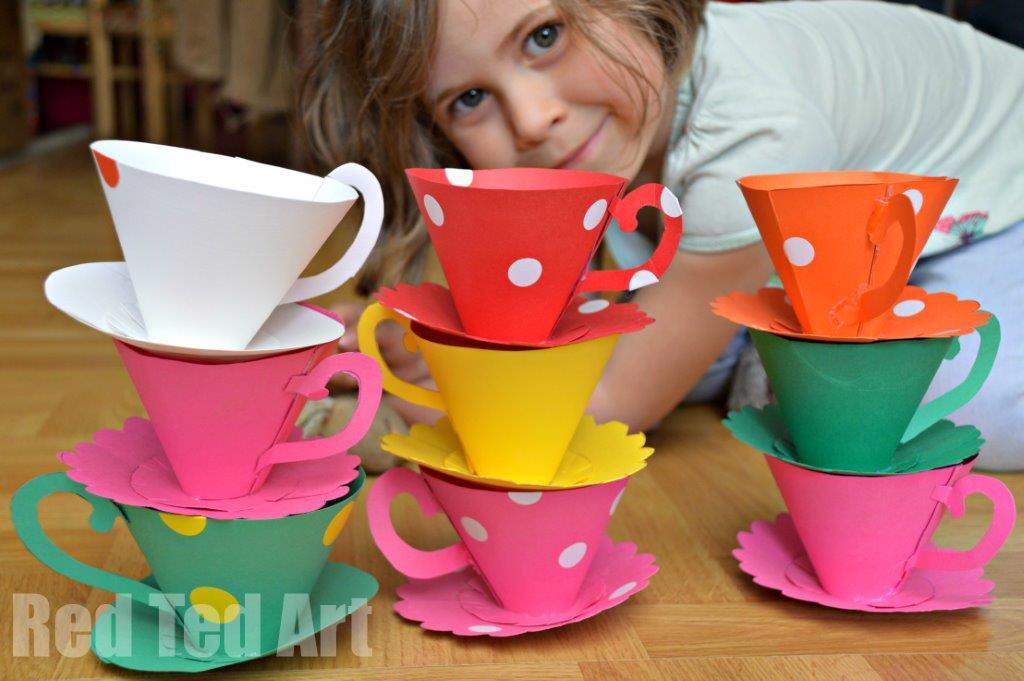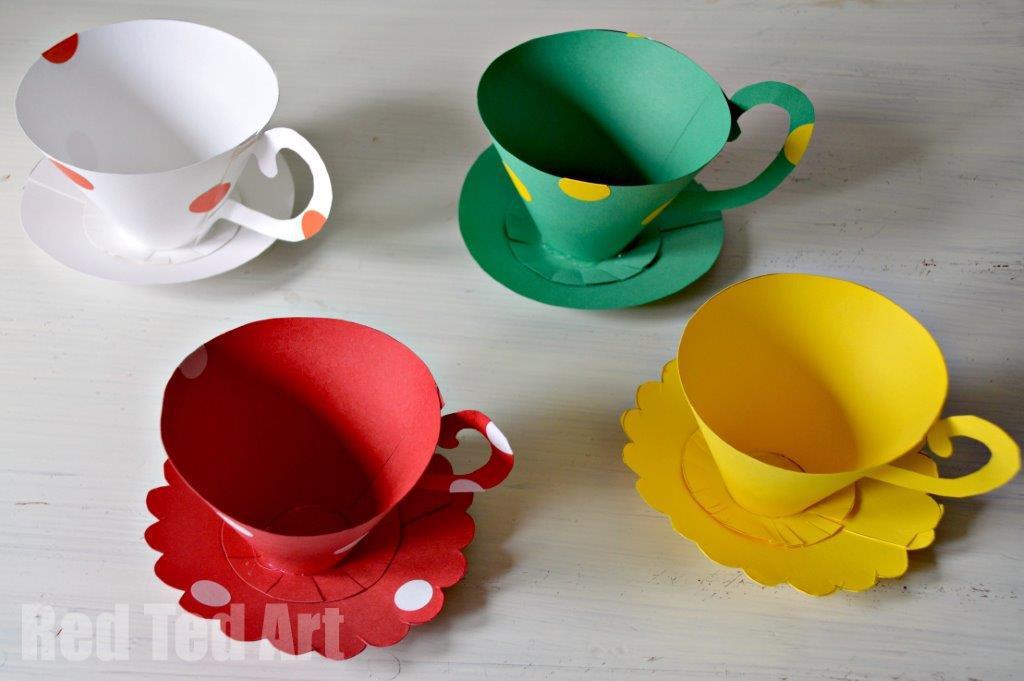The first image is the image on the left, the second image is the image on the right. Considering the images on both sides, is "An image shows at least two stacks of at least three cups on matching saucers, featuring different solid colors, polka dots, and scalloped edges." valid? Answer yes or no. Yes. The first image is the image on the left, the second image is the image on the right. Assess this claim about the two images: "There is a solid white cup.". Correct or not? Answer yes or no. No. 